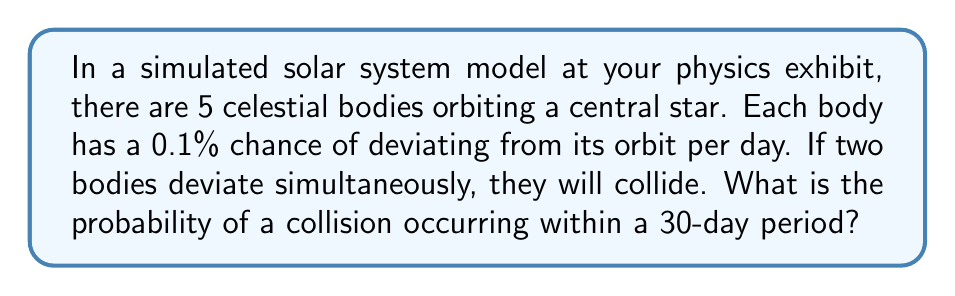What is the answer to this math problem? Let's approach this step-by-step:

1) First, we need to calculate the probability of two specific bodies deviating on the same day:
   $P(\text{two specific bodies deviate}) = 0.001 \times 0.001 = 0.000001 = 10^{-6}$

2) There are $\binom{5}{2} = 10$ possible pairs of bodies that could collide. So for any given day, the probability of a collision is:
   $P(\text{collision in one day}) = 10 \times 10^{-6} = 10^{-5}$

3) The probability of no collision in one day is therefore:
   $P(\text{no collision in one day}) = 1 - 10^{-5} = 0.99999$

4) For no collision to occur in 30 days, we need 30 consecutive days without a collision. The probability of this is:
   $P(\text{no collision in 30 days}) = (0.99999)^{30} \approx 0.9997$

5) Therefore, the probability of at least one collision in 30 days is:
   $P(\text{collision in 30 days}) = 1 - P(\text{no collision in 30 days})$
   $= 1 - 0.9997 = 0.0003 = 0.03\%$
Answer: $0.03\%$ 